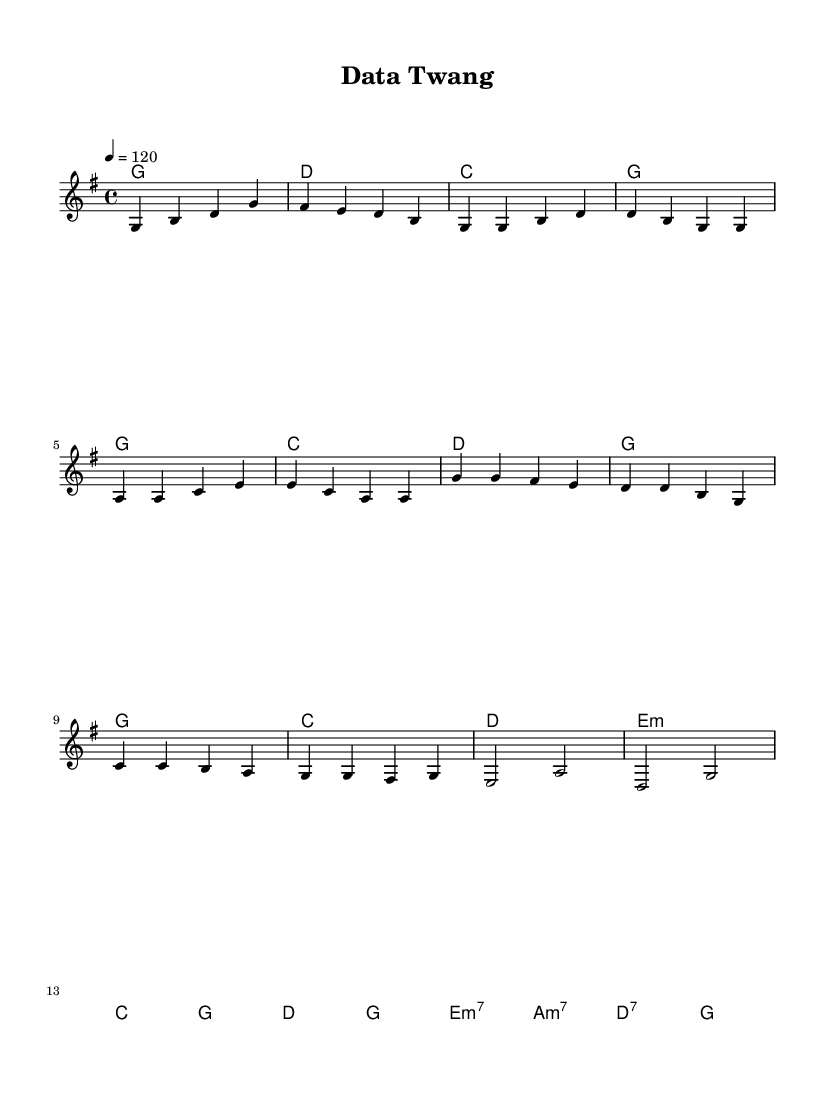what is the key signature of this music? The key signature is indicated by the presence of one sharp, which is associated with G major. This can be identified by looking at the beginning of the staff, where the sharp symbol appears.
Answer: G major what is the time signature of this music? The time signature is found at the beginning of the score next to the key signature. It displays a "4/4", meaning there are four beats in each measure and the quarter note receives one beat.
Answer: 4/4 what is the tempo marking of this music? The tempo marking is indicated in beats per minute (BPM) and is stated as "4 = 120". This means there should be 120 beats per minute, serving as the pulse of the music.
Answer: 120 which chord is played during the chorus first? The chorus begins with the chord 'g' in the score. We can see this indicated in the harmonies section where the first chord corresponding to the chorus section is noted.
Answer: g how many measures are there in the bridge section? To find the number of measures, we look at the bridge section in the score, which consists of two lines of music. Each line consists of one measure, indicating there are a total of two measures in the bridge.
Answer: 2 what is the main thematic element of the verse? The main thematic element of the verse is established primarily through repetition, as indicated by the repeated use of the pitch 'g' at the start of the verse section, typical of country rock's storytelling style.
Answer: repetition how does the structure of this piece reflect country rock characteristics? The structure features a clear verse-chorus form, which is indicative of country rock. It integrates narrative melody lines and guitar-like harmonies, creating a relatable storytelling experience typical of the genre.
Answer: verse-chorus form 